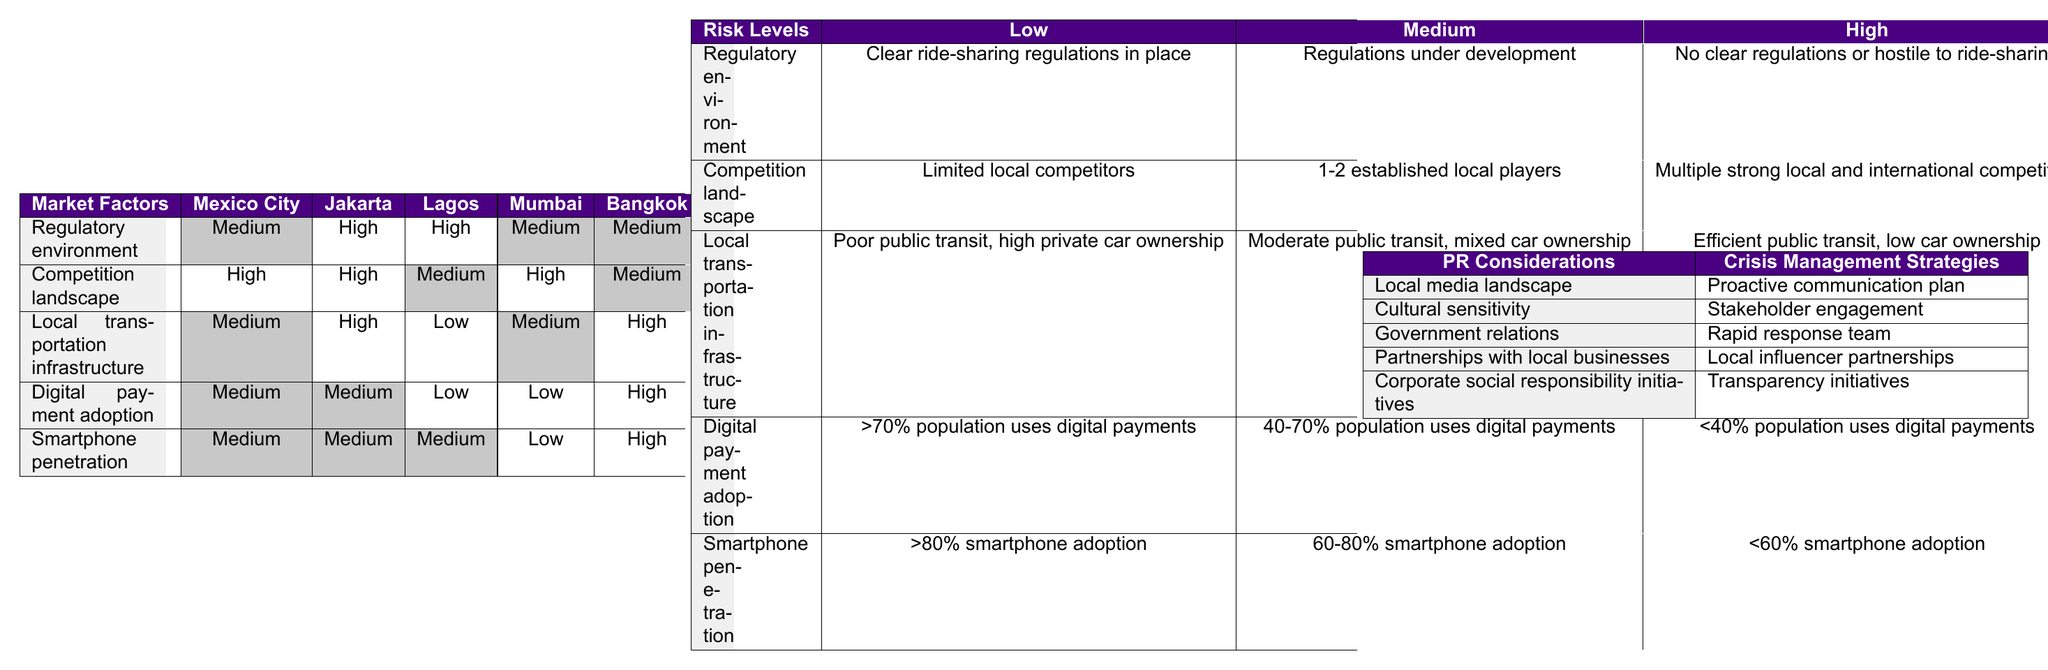What is the regulatory environment risk level in Mexico City? The table indicates that the regulatory environment in Mexico City is assessed as Medium. This is directly stated in the table where Mexico City aligns with the Medium value for the regulatory environment risk.
Answer: Medium Which market has the highest competition landscape risk? According to the table, both Mexico City and Jakarta have a High competition landscape risk. This is visible in the respective rows for competition landscape, matching the High value for each of these markets.
Answer: Mexico City and Jakarta Is digital payment adoption Low in Lagos? The table shows that the digital payment adoption risk level in Lagos is Low, as indicated in the corresponding row for Lagos. The value of Low is visually presented in the table for this market.
Answer: Yes Which market has the lowest score for local transportation infrastructure? The table reveals that Lagos has a Low risk in terms of local transportation infrastructure. This is the only Low score represented in that particular evaluation criterion within the table for any of the markets listed.
Answer: Lagos What is the average risk level for smartphone penetration across all potential markets? To calculate the average risk level for smartphone penetration, identify the risk values: Mexico City (Medium), Jakarta (Medium), Lagos (Medium), Mumbai (Low), and Bangkok (High). Assign values: Low=1, Medium=2, High=3. The sum is 2 + 2 + 2 + 1 + 3 = 10, and the average is 10/5 = 2, which corresponds to Medium.
Answer: Medium Does Bangkok have a favorable environment for ride-sharing based on the table? Yes, the table indicates that Bangkok has Medium regulatory environment and competition landscape, High local transportation infrastructure, and High digital payment adoption and smartphone penetration. Each of these aspects suggests potential favorability for ride-sharing operations.
Answer: Yes How does the competition landscape in Mumbai compare to that in Jakarta? The table states that the competition landscape in Mumbai is High, whereas in Jakarta, it is also assessed as High. Therefore, both markets have the same risk level for competition landscape, suggesting they're equally challenging in terms of competition.
Answer: They are the same (High) Which potential market has the lowest adoption of digital payments, and how does this affect risk assessment? Lagos has the lowest digital payment adoption risk, marked as Low in the table. This indicates a significant barrier to potential ride-sharing success, as low digital payment adoption can hinder transaction facilitation and user engagement.
Answer: Lagos; it affects negatively What crisis management strategy pairs well with proactive communication? The table suggests that stakeholder engagement pairs well with proactive communication as it is listed alongside it as a sequential consideration. Proactive communication sets the stage for effective dialogue, supported by stakeholder engagement strategies.
Answer: Stakeholder engagement 